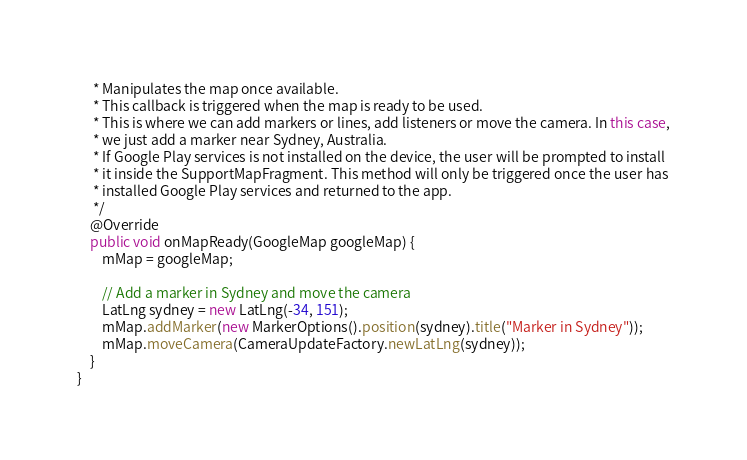<code> <loc_0><loc_0><loc_500><loc_500><_Java_>     * Manipulates the map once available.
     * This callback is triggered when the map is ready to be used.
     * This is where we can add markers or lines, add listeners or move the camera. In this case,
     * we just add a marker near Sydney, Australia.
     * If Google Play services is not installed on the device, the user will be prompted to install
     * it inside the SupportMapFragment. This method will only be triggered once the user has
     * installed Google Play services and returned to the app.
     */
    @Override
    public void onMapReady(GoogleMap googleMap) {
        mMap = googleMap;

        // Add a marker in Sydney and move the camera
        LatLng sydney = new LatLng(-34, 151);
        mMap.addMarker(new MarkerOptions().position(sydney).title("Marker in Sydney"));
        mMap.moveCamera(CameraUpdateFactory.newLatLng(sydney));
    }
}</code> 